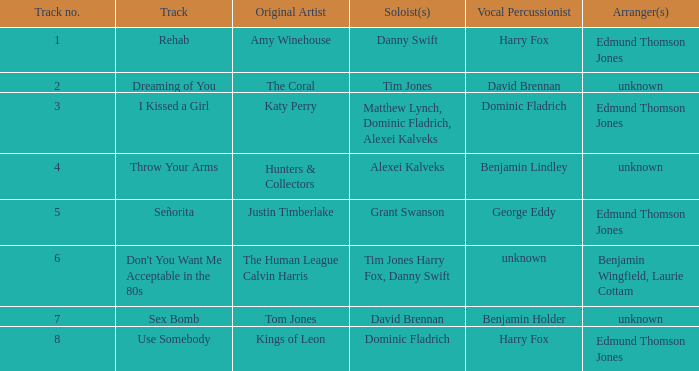Which artist first created "use somebody"? Kings of Leon. 